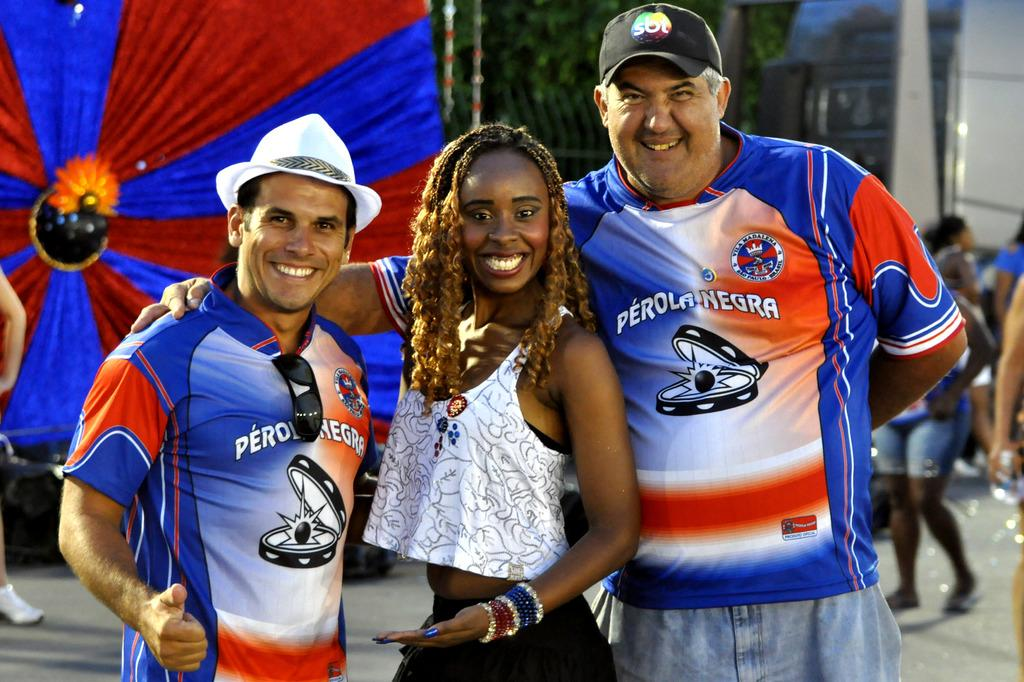<image>
Give a short and clear explanation of the subsequent image. a perola negro shirt is on two men and a lady poses with them 